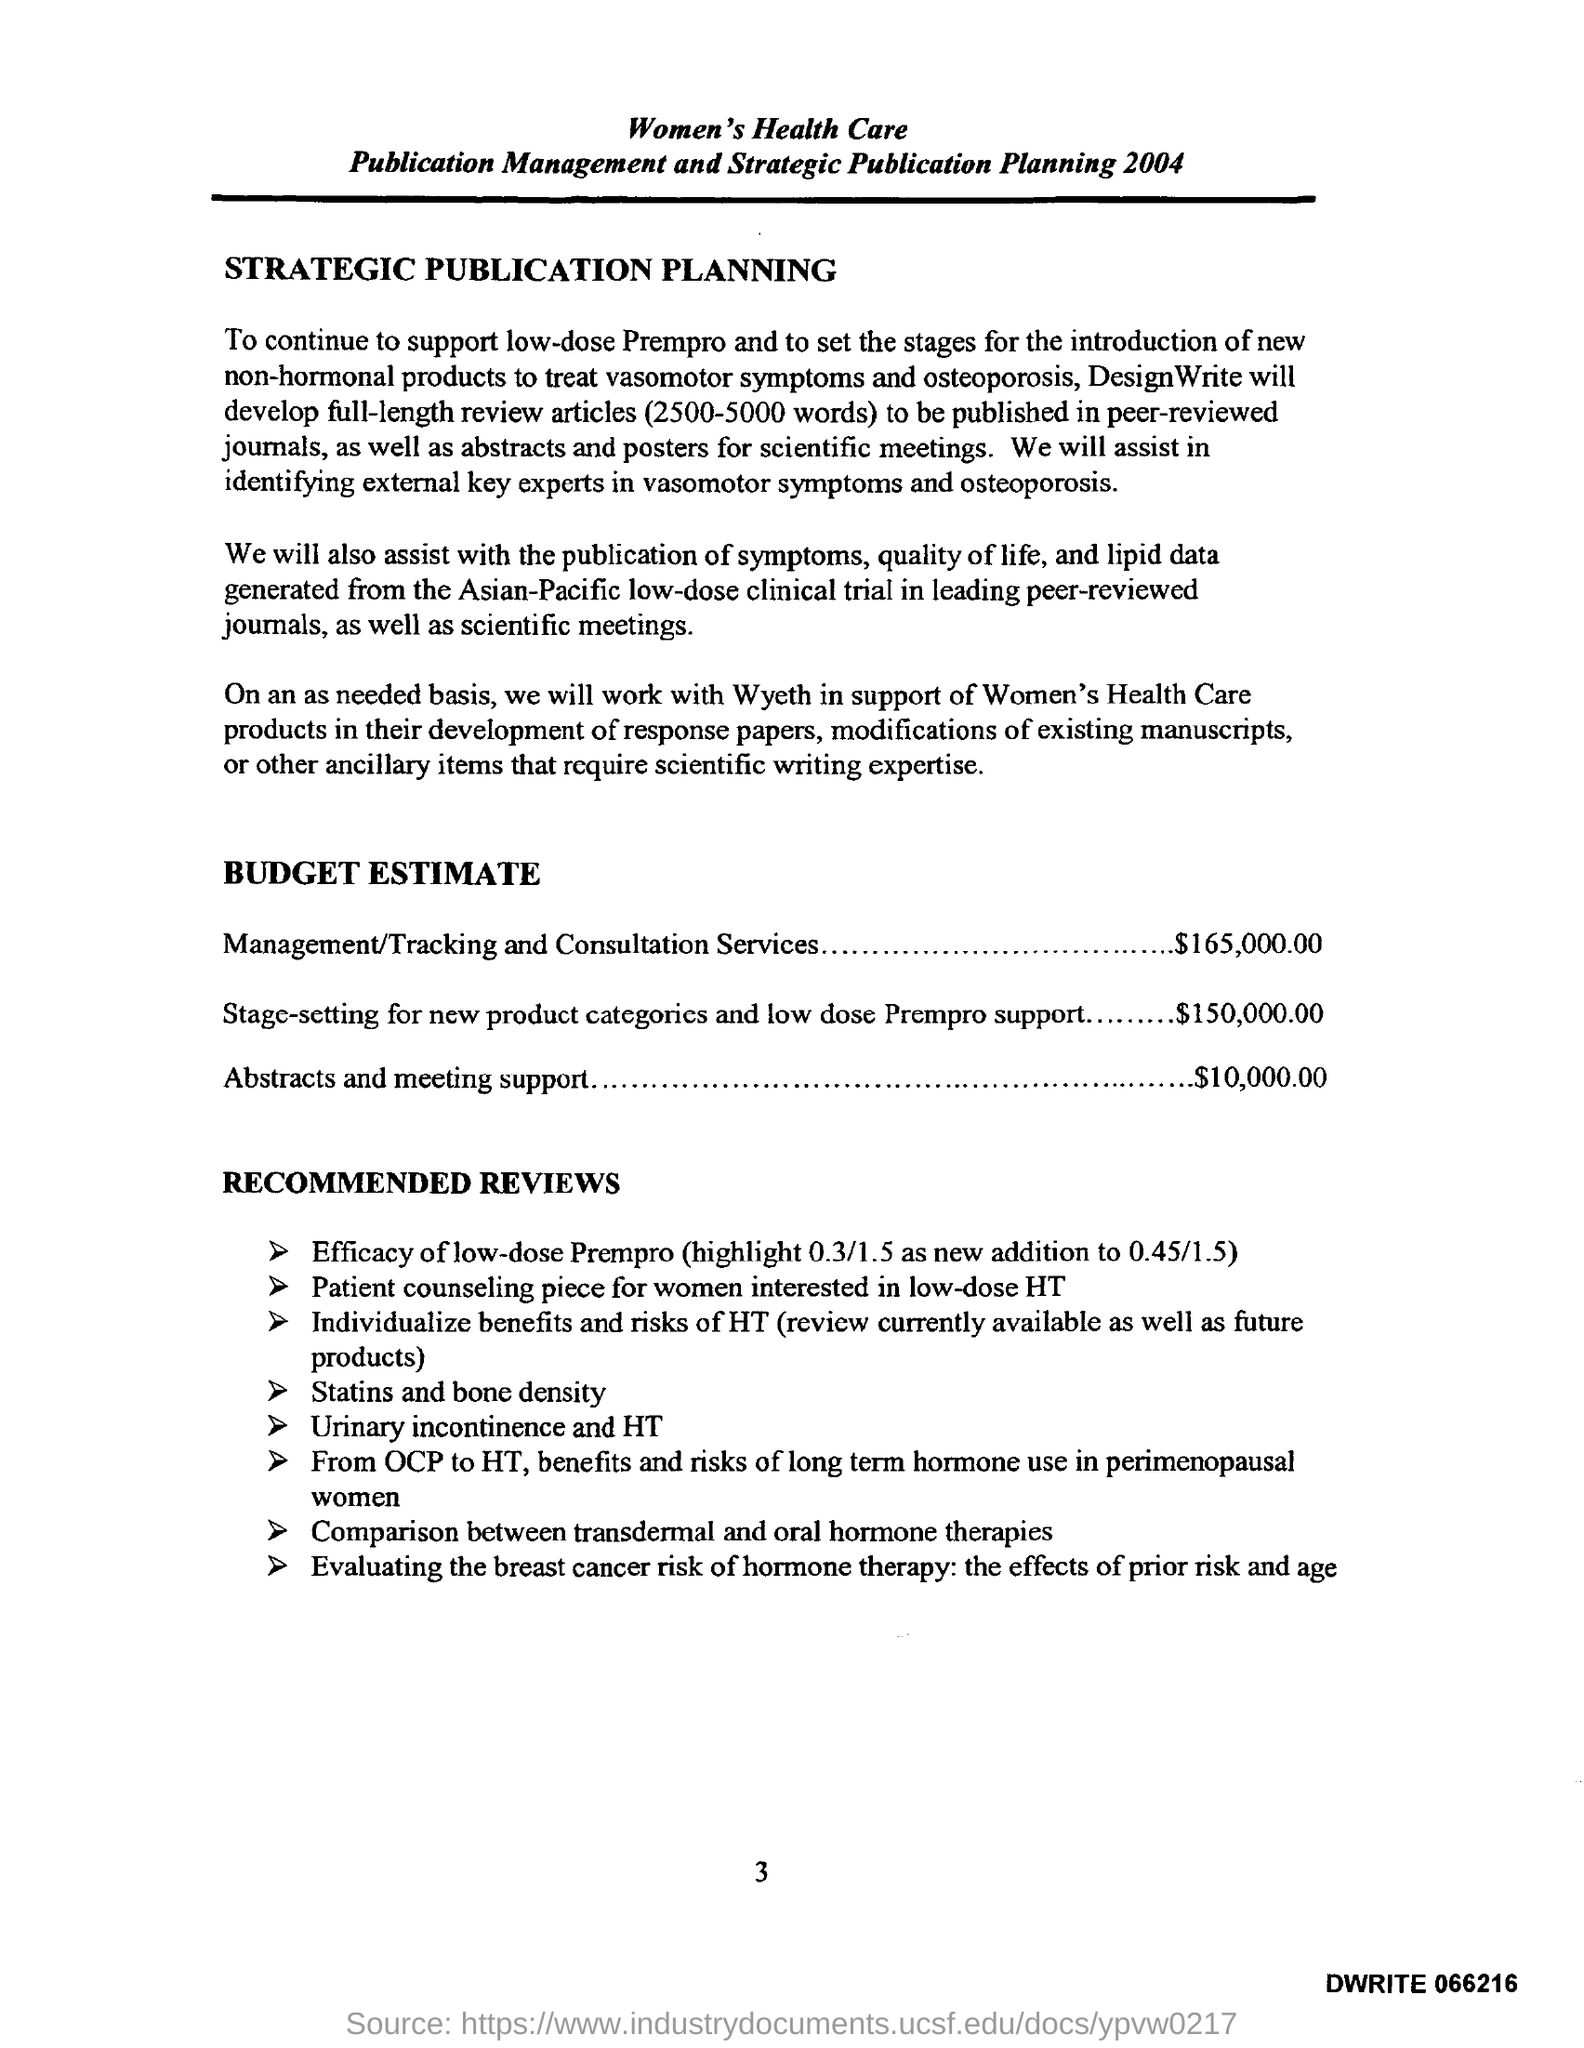Highlight a few significant elements in this photo. The budget estimate for abstracts and meeting support is $10,000.00. The page number mentioned in this document is 3. The estimated budget for setting up new product categories and providing low-dose Prempro support is $150,000.00. 